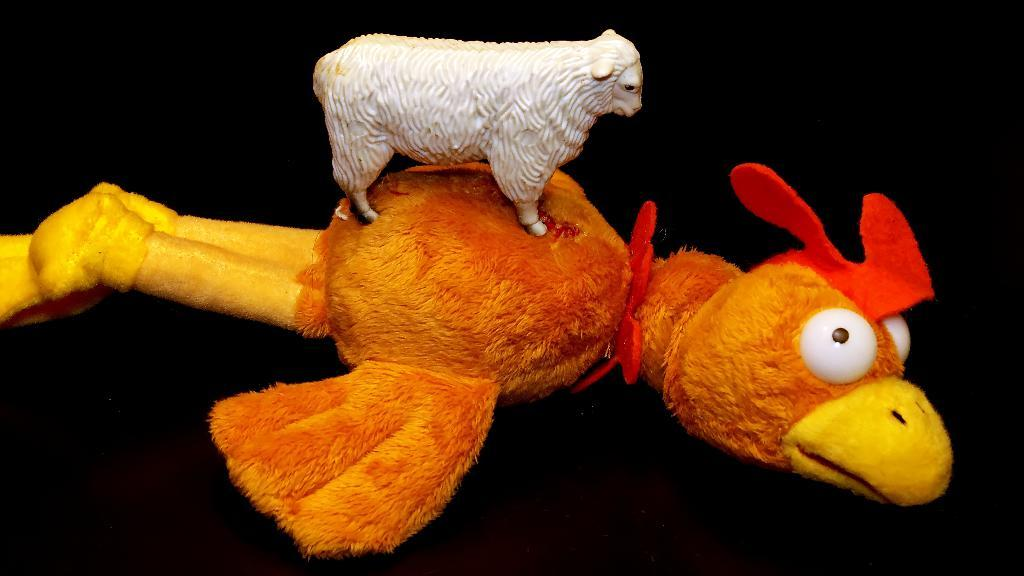What is the main subject in the center of the image? There is an orange color soft toy in the center of the image. What is depicted on the soft toy? The soft toy has a sheep depiction on top. What color is the background of the image? The background of the image is in black color. What type of copper material is used to create the caption in the image? There is no caption present in the image, and therefore no copper material is used. 